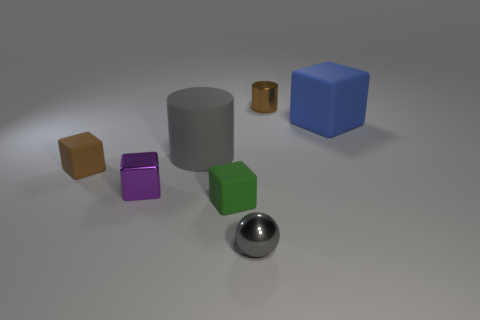Subtract all metallic cubes. How many cubes are left? 3 Add 2 tiny brown rubber spheres. How many objects exist? 9 Subtract all purple blocks. How many blocks are left? 3 Subtract 1 spheres. How many spheres are left? 0 Subtract all cylinders. How many objects are left? 5 Subtract all big blue metal cubes. Subtract all small rubber things. How many objects are left? 5 Add 5 blue blocks. How many blue blocks are left? 6 Add 5 green rubber cubes. How many green rubber cubes exist? 6 Subtract 1 purple blocks. How many objects are left? 6 Subtract all red spheres. Subtract all red cubes. How many spheres are left? 1 